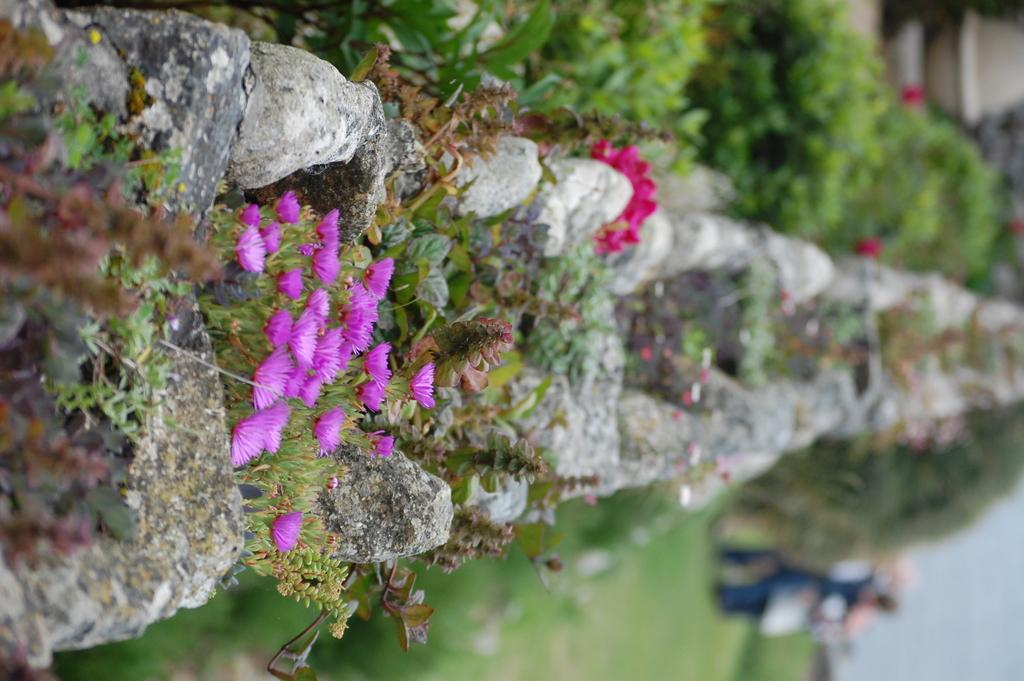What is a prominent feature on the left side of the image? There is a wall in the image. What is attached to the wall? Plants and flowers are present on the wall. What type of vegetation is located beside the wall? There are plants beside the wall. What is the ground surface like beside the wall? Grass is visible beside the wall. What color is the shirt worn by the hair on the right side of the image? There is no shirt or hair present on the right side of the image, as it is blurred. 